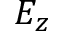Convert formula to latex. <formula><loc_0><loc_0><loc_500><loc_500>E _ { z }</formula> 